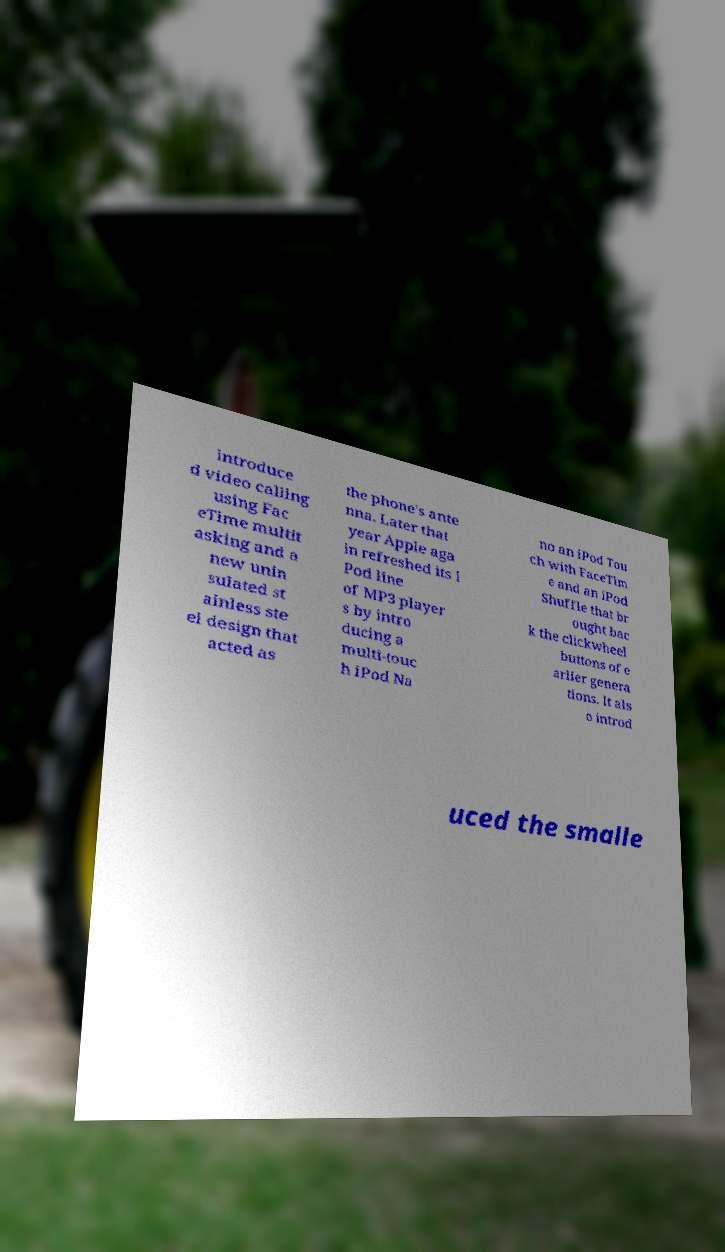For documentation purposes, I need the text within this image transcribed. Could you provide that? introduce d video calling using Fac eTime multit asking and a new unin sulated st ainless ste el design that acted as the phone's ante nna. Later that year Apple aga in refreshed its i Pod line of MP3 player s by intro ducing a multi-touc h iPod Na no an iPod Tou ch with FaceTim e and an iPod Shuffle that br ought bac k the clickwheel buttons of e arlier genera tions. It als o introd uced the smalle 